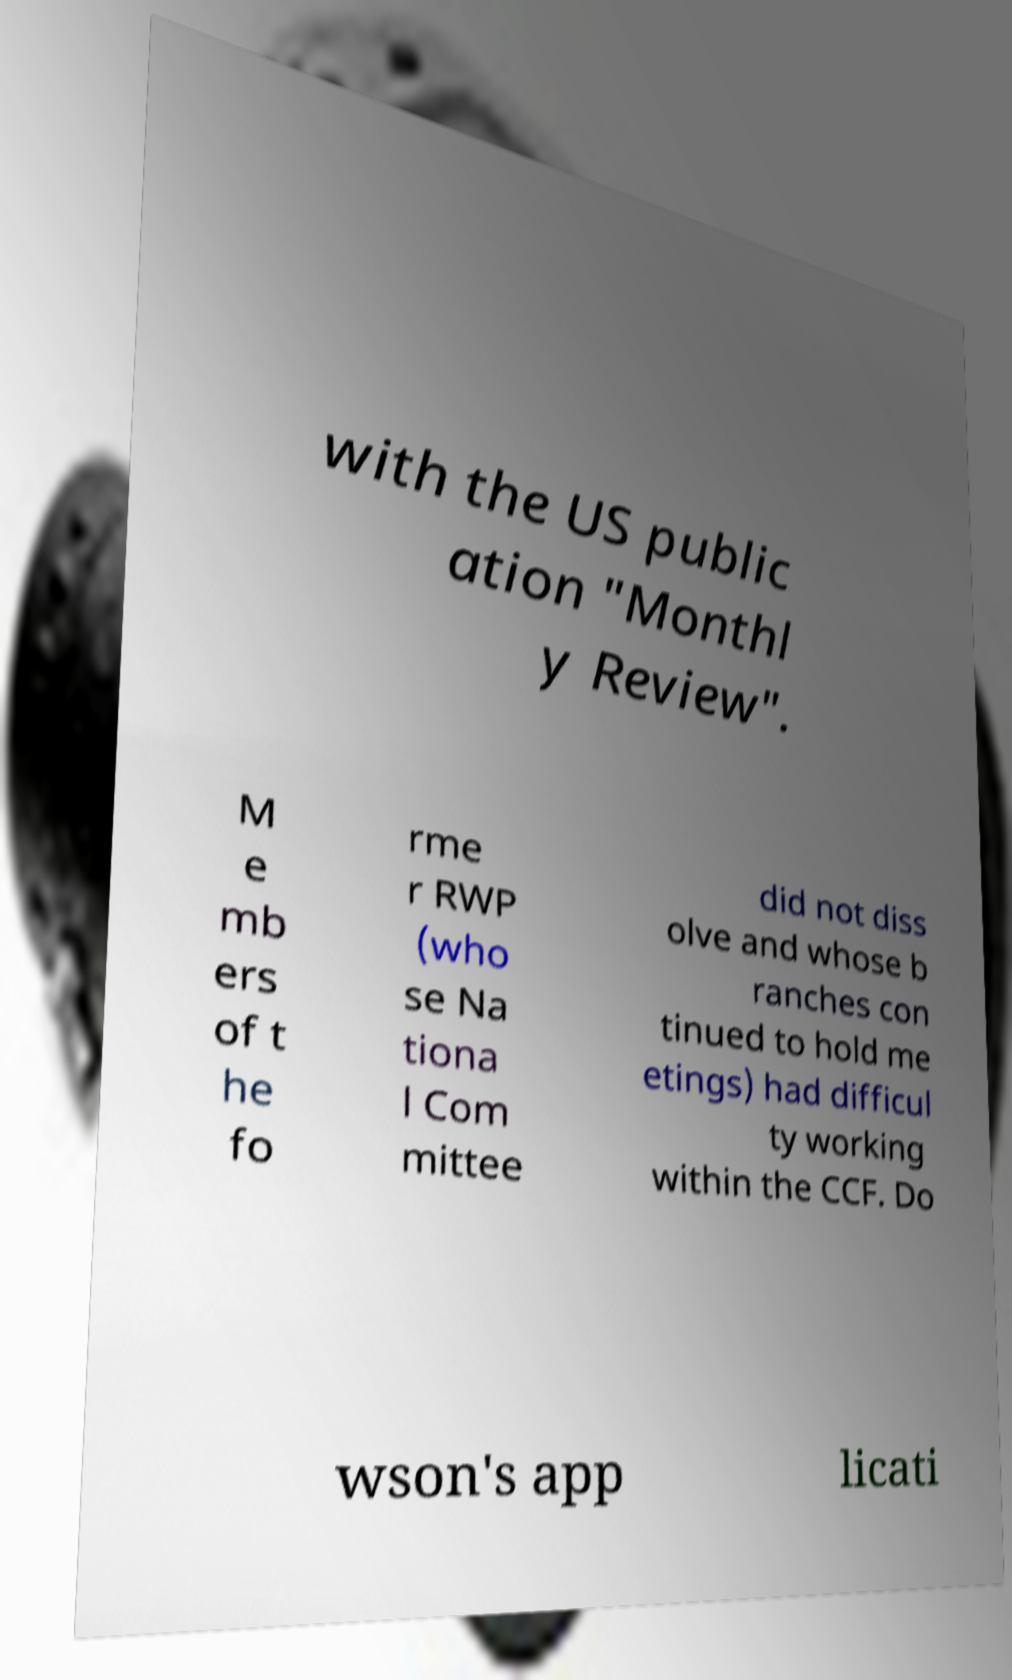Please read and relay the text visible in this image. What does it say? with the US public ation "Monthl y Review". M e mb ers of t he fo rme r RWP (who se Na tiona l Com mittee did not diss olve and whose b ranches con tinued to hold me etings) had difficul ty working within the CCF. Do wson's app licati 